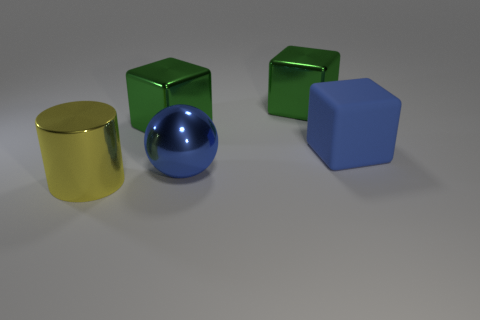Subtract all large green metallic cubes. How many cubes are left? 1 Add 1 yellow objects. How many objects exist? 6 Subtract all blue cubes. How many cubes are left? 2 Subtract all cyan balls. How many green blocks are left? 2 Subtract all spheres. How many objects are left? 4 Subtract all metal cylinders. Subtract all rubber cubes. How many objects are left? 3 Add 4 blue rubber blocks. How many blue rubber blocks are left? 5 Add 5 big balls. How many big balls exist? 6 Subtract 1 yellow cylinders. How many objects are left? 4 Subtract all red cylinders. Subtract all blue blocks. How many cylinders are left? 1 